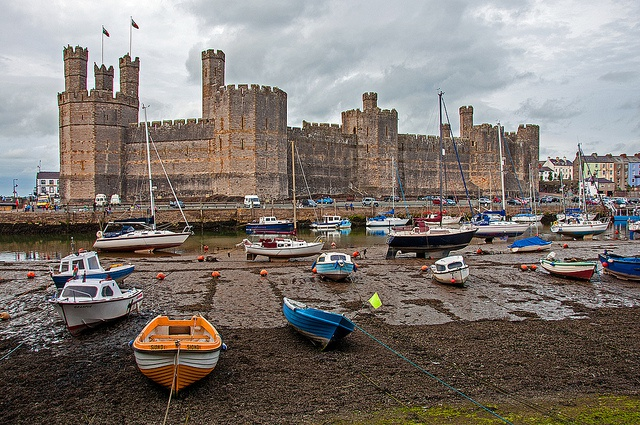Describe the objects in this image and their specific colors. I can see boat in lightgray, black, gray, and darkgray tones, boat in lightgray, black, red, maroon, and brown tones, boat in lightgray, gray, black, and darkgray tones, boat in lightgray, black, darkgray, and gray tones, and boat in lightgray, black, navy, teal, and blue tones in this image. 